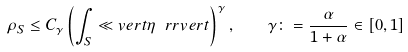Convert formula to latex. <formula><loc_0><loc_0><loc_500><loc_500>\rho _ { S } \leq C _ { \gamma } \left ( \int _ { S } \ll v e r t \eta \ r r v e r t \right ) ^ { \gamma } , \quad \gamma \colon = \frac { \alpha } { 1 + \alpha } \in [ 0 , 1 ]</formula> 